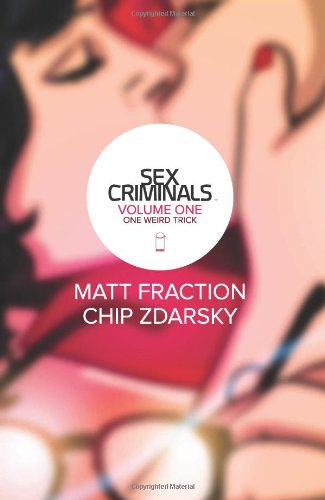What type of book is this? This is a graphic novel under the category of Comics & Graphic Novels, known for its unique storytelling and artistic illustration that covers adult themes with humor and depth. 